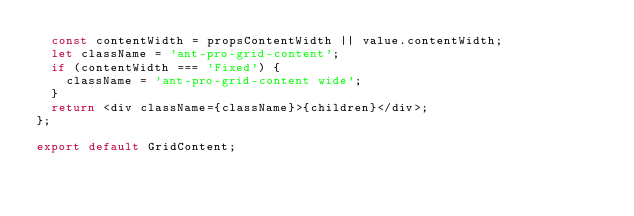<code> <loc_0><loc_0><loc_500><loc_500><_TypeScript_>  const contentWidth = propsContentWidth || value.contentWidth;
  let className = 'ant-pro-grid-content';
  if (contentWidth === 'Fixed') {
    className = 'ant-pro-grid-content wide';
  }
  return <div className={className}>{children}</div>;
};

export default GridContent;
</code> 